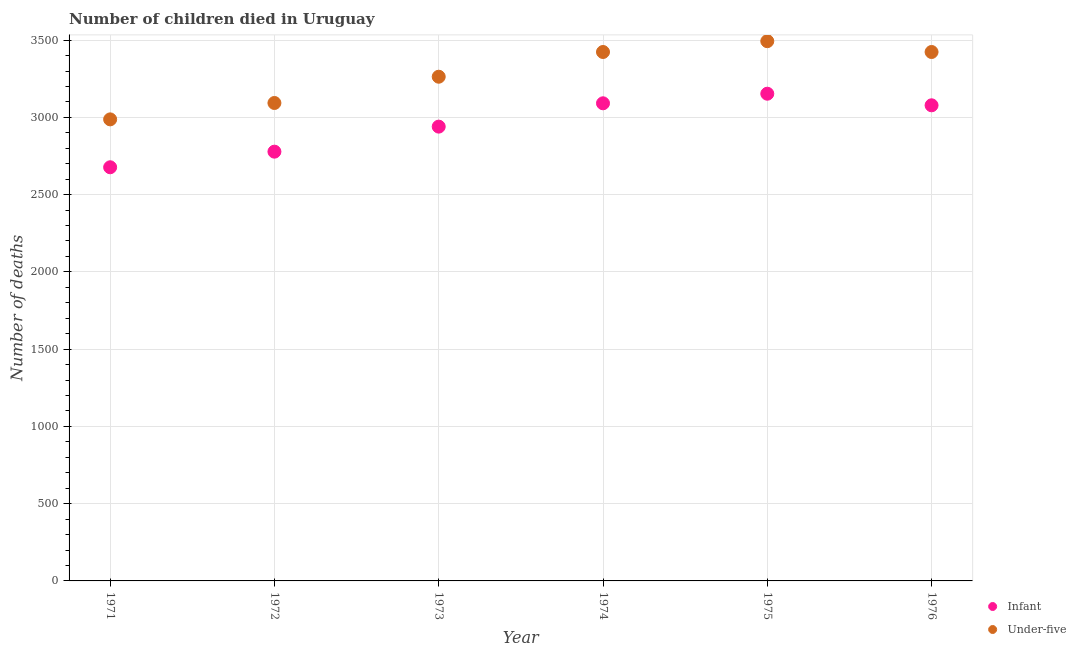Is the number of dotlines equal to the number of legend labels?
Your answer should be compact. Yes. What is the number of infant deaths in 1973?
Offer a terse response. 2940. Across all years, what is the maximum number of under-five deaths?
Provide a short and direct response. 3493. Across all years, what is the minimum number of under-five deaths?
Your answer should be compact. 2987. In which year was the number of infant deaths maximum?
Provide a short and direct response. 1975. What is the total number of infant deaths in the graph?
Provide a short and direct response. 1.77e+04. What is the difference between the number of infant deaths in 1972 and that in 1976?
Your answer should be very brief. -300. What is the difference between the number of under-five deaths in 1975 and the number of infant deaths in 1971?
Provide a succinct answer. 816. What is the average number of infant deaths per year?
Your response must be concise. 2952.83. In the year 1976, what is the difference between the number of under-five deaths and number of infant deaths?
Make the answer very short. 345. In how many years, is the number of infant deaths greater than 2700?
Keep it short and to the point. 5. What is the ratio of the number of infant deaths in 1971 to that in 1972?
Your answer should be compact. 0.96. Is the number of under-five deaths in 1972 less than that in 1976?
Provide a short and direct response. Yes. What is the difference between the highest and the second highest number of infant deaths?
Offer a terse response. 62. What is the difference between the highest and the lowest number of under-five deaths?
Provide a succinct answer. 506. In how many years, is the number of infant deaths greater than the average number of infant deaths taken over all years?
Provide a short and direct response. 3. Is the sum of the number of infant deaths in 1973 and 1976 greater than the maximum number of under-five deaths across all years?
Provide a succinct answer. Yes. How many dotlines are there?
Ensure brevity in your answer.  2. How many years are there in the graph?
Make the answer very short. 6. What is the difference between two consecutive major ticks on the Y-axis?
Keep it short and to the point. 500. Where does the legend appear in the graph?
Give a very brief answer. Bottom right. How many legend labels are there?
Your answer should be very brief. 2. What is the title of the graph?
Keep it short and to the point. Number of children died in Uruguay. What is the label or title of the Y-axis?
Ensure brevity in your answer.  Number of deaths. What is the Number of deaths of Infant in 1971?
Give a very brief answer. 2677. What is the Number of deaths in Under-five in 1971?
Your answer should be very brief. 2987. What is the Number of deaths of Infant in 1972?
Your response must be concise. 2778. What is the Number of deaths in Under-five in 1972?
Offer a terse response. 3093. What is the Number of deaths of Infant in 1973?
Make the answer very short. 2940. What is the Number of deaths in Under-five in 1973?
Offer a terse response. 3263. What is the Number of deaths in Infant in 1974?
Ensure brevity in your answer.  3091. What is the Number of deaths in Under-five in 1974?
Provide a short and direct response. 3423. What is the Number of deaths of Infant in 1975?
Offer a very short reply. 3153. What is the Number of deaths of Under-five in 1975?
Your answer should be compact. 3493. What is the Number of deaths of Infant in 1976?
Make the answer very short. 3078. What is the Number of deaths in Under-five in 1976?
Your answer should be compact. 3423. Across all years, what is the maximum Number of deaths in Infant?
Offer a very short reply. 3153. Across all years, what is the maximum Number of deaths in Under-five?
Offer a very short reply. 3493. Across all years, what is the minimum Number of deaths of Infant?
Your answer should be very brief. 2677. Across all years, what is the minimum Number of deaths in Under-five?
Keep it short and to the point. 2987. What is the total Number of deaths in Infant in the graph?
Offer a very short reply. 1.77e+04. What is the total Number of deaths in Under-five in the graph?
Your response must be concise. 1.97e+04. What is the difference between the Number of deaths in Infant in 1971 and that in 1972?
Offer a terse response. -101. What is the difference between the Number of deaths of Under-five in 1971 and that in 1972?
Keep it short and to the point. -106. What is the difference between the Number of deaths in Infant in 1971 and that in 1973?
Ensure brevity in your answer.  -263. What is the difference between the Number of deaths in Under-five in 1971 and that in 1973?
Your response must be concise. -276. What is the difference between the Number of deaths in Infant in 1971 and that in 1974?
Provide a succinct answer. -414. What is the difference between the Number of deaths in Under-five in 1971 and that in 1974?
Ensure brevity in your answer.  -436. What is the difference between the Number of deaths in Infant in 1971 and that in 1975?
Your response must be concise. -476. What is the difference between the Number of deaths in Under-five in 1971 and that in 1975?
Offer a very short reply. -506. What is the difference between the Number of deaths in Infant in 1971 and that in 1976?
Offer a very short reply. -401. What is the difference between the Number of deaths in Under-five in 1971 and that in 1976?
Provide a short and direct response. -436. What is the difference between the Number of deaths of Infant in 1972 and that in 1973?
Offer a terse response. -162. What is the difference between the Number of deaths of Under-five in 1972 and that in 1973?
Offer a very short reply. -170. What is the difference between the Number of deaths of Infant in 1972 and that in 1974?
Offer a very short reply. -313. What is the difference between the Number of deaths in Under-five in 1972 and that in 1974?
Offer a terse response. -330. What is the difference between the Number of deaths of Infant in 1972 and that in 1975?
Give a very brief answer. -375. What is the difference between the Number of deaths of Under-five in 1972 and that in 1975?
Ensure brevity in your answer.  -400. What is the difference between the Number of deaths of Infant in 1972 and that in 1976?
Provide a short and direct response. -300. What is the difference between the Number of deaths in Under-five in 1972 and that in 1976?
Ensure brevity in your answer.  -330. What is the difference between the Number of deaths of Infant in 1973 and that in 1974?
Make the answer very short. -151. What is the difference between the Number of deaths in Under-five in 1973 and that in 1974?
Make the answer very short. -160. What is the difference between the Number of deaths in Infant in 1973 and that in 1975?
Provide a short and direct response. -213. What is the difference between the Number of deaths in Under-five in 1973 and that in 1975?
Keep it short and to the point. -230. What is the difference between the Number of deaths in Infant in 1973 and that in 1976?
Offer a terse response. -138. What is the difference between the Number of deaths in Under-five in 1973 and that in 1976?
Offer a terse response. -160. What is the difference between the Number of deaths of Infant in 1974 and that in 1975?
Your response must be concise. -62. What is the difference between the Number of deaths in Under-five in 1974 and that in 1975?
Your answer should be very brief. -70. What is the difference between the Number of deaths of Under-five in 1974 and that in 1976?
Your answer should be very brief. 0. What is the difference between the Number of deaths of Under-five in 1975 and that in 1976?
Your answer should be compact. 70. What is the difference between the Number of deaths of Infant in 1971 and the Number of deaths of Under-five in 1972?
Your answer should be very brief. -416. What is the difference between the Number of deaths of Infant in 1971 and the Number of deaths of Under-five in 1973?
Provide a succinct answer. -586. What is the difference between the Number of deaths in Infant in 1971 and the Number of deaths in Under-five in 1974?
Offer a terse response. -746. What is the difference between the Number of deaths of Infant in 1971 and the Number of deaths of Under-five in 1975?
Your answer should be very brief. -816. What is the difference between the Number of deaths in Infant in 1971 and the Number of deaths in Under-five in 1976?
Offer a very short reply. -746. What is the difference between the Number of deaths of Infant in 1972 and the Number of deaths of Under-five in 1973?
Ensure brevity in your answer.  -485. What is the difference between the Number of deaths in Infant in 1972 and the Number of deaths in Under-five in 1974?
Your response must be concise. -645. What is the difference between the Number of deaths of Infant in 1972 and the Number of deaths of Under-five in 1975?
Offer a very short reply. -715. What is the difference between the Number of deaths of Infant in 1972 and the Number of deaths of Under-five in 1976?
Provide a short and direct response. -645. What is the difference between the Number of deaths in Infant in 1973 and the Number of deaths in Under-five in 1974?
Provide a short and direct response. -483. What is the difference between the Number of deaths of Infant in 1973 and the Number of deaths of Under-five in 1975?
Keep it short and to the point. -553. What is the difference between the Number of deaths in Infant in 1973 and the Number of deaths in Under-five in 1976?
Provide a short and direct response. -483. What is the difference between the Number of deaths of Infant in 1974 and the Number of deaths of Under-five in 1975?
Your answer should be compact. -402. What is the difference between the Number of deaths of Infant in 1974 and the Number of deaths of Under-five in 1976?
Give a very brief answer. -332. What is the difference between the Number of deaths in Infant in 1975 and the Number of deaths in Under-five in 1976?
Provide a short and direct response. -270. What is the average Number of deaths of Infant per year?
Your answer should be compact. 2952.83. What is the average Number of deaths in Under-five per year?
Offer a very short reply. 3280.33. In the year 1971, what is the difference between the Number of deaths in Infant and Number of deaths in Under-five?
Make the answer very short. -310. In the year 1972, what is the difference between the Number of deaths in Infant and Number of deaths in Under-five?
Offer a terse response. -315. In the year 1973, what is the difference between the Number of deaths of Infant and Number of deaths of Under-five?
Your response must be concise. -323. In the year 1974, what is the difference between the Number of deaths in Infant and Number of deaths in Under-five?
Provide a succinct answer. -332. In the year 1975, what is the difference between the Number of deaths in Infant and Number of deaths in Under-five?
Offer a very short reply. -340. In the year 1976, what is the difference between the Number of deaths in Infant and Number of deaths in Under-five?
Offer a terse response. -345. What is the ratio of the Number of deaths of Infant in 1971 to that in 1972?
Your answer should be compact. 0.96. What is the ratio of the Number of deaths in Under-five in 1971 to that in 1972?
Offer a terse response. 0.97. What is the ratio of the Number of deaths in Infant in 1971 to that in 1973?
Provide a short and direct response. 0.91. What is the ratio of the Number of deaths in Under-five in 1971 to that in 1973?
Provide a short and direct response. 0.92. What is the ratio of the Number of deaths in Infant in 1971 to that in 1974?
Your answer should be very brief. 0.87. What is the ratio of the Number of deaths of Under-five in 1971 to that in 1974?
Provide a succinct answer. 0.87. What is the ratio of the Number of deaths in Infant in 1971 to that in 1975?
Make the answer very short. 0.85. What is the ratio of the Number of deaths of Under-five in 1971 to that in 1975?
Offer a very short reply. 0.86. What is the ratio of the Number of deaths of Infant in 1971 to that in 1976?
Offer a terse response. 0.87. What is the ratio of the Number of deaths in Under-five in 1971 to that in 1976?
Give a very brief answer. 0.87. What is the ratio of the Number of deaths of Infant in 1972 to that in 1973?
Offer a terse response. 0.94. What is the ratio of the Number of deaths in Under-five in 1972 to that in 1973?
Make the answer very short. 0.95. What is the ratio of the Number of deaths of Infant in 1972 to that in 1974?
Offer a terse response. 0.9. What is the ratio of the Number of deaths in Under-five in 1972 to that in 1974?
Give a very brief answer. 0.9. What is the ratio of the Number of deaths of Infant in 1972 to that in 1975?
Provide a succinct answer. 0.88. What is the ratio of the Number of deaths of Under-five in 1972 to that in 1975?
Give a very brief answer. 0.89. What is the ratio of the Number of deaths in Infant in 1972 to that in 1976?
Your response must be concise. 0.9. What is the ratio of the Number of deaths of Under-five in 1972 to that in 1976?
Keep it short and to the point. 0.9. What is the ratio of the Number of deaths of Infant in 1973 to that in 1974?
Make the answer very short. 0.95. What is the ratio of the Number of deaths of Under-five in 1973 to that in 1974?
Offer a terse response. 0.95. What is the ratio of the Number of deaths in Infant in 1973 to that in 1975?
Your answer should be very brief. 0.93. What is the ratio of the Number of deaths of Under-five in 1973 to that in 1975?
Provide a succinct answer. 0.93. What is the ratio of the Number of deaths of Infant in 1973 to that in 1976?
Your answer should be compact. 0.96. What is the ratio of the Number of deaths in Under-five in 1973 to that in 1976?
Ensure brevity in your answer.  0.95. What is the ratio of the Number of deaths in Infant in 1974 to that in 1975?
Your answer should be compact. 0.98. What is the ratio of the Number of deaths in Infant in 1975 to that in 1976?
Offer a terse response. 1.02. What is the ratio of the Number of deaths in Under-five in 1975 to that in 1976?
Offer a very short reply. 1.02. What is the difference between the highest and the second highest Number of deaths in Infant?
Your answer should be compact. 62. What is the difference between the highest and the second highest Number of deaths of Under-five?
Ensure brevity in your answer.  70. What is the difference between the highest and the lowest Number of deaths of Infant?
Provide a succinct answer. 476. What is the difference between the highest and the lowest Number of deaths of Under-five?
Offer a terse response. 506. 